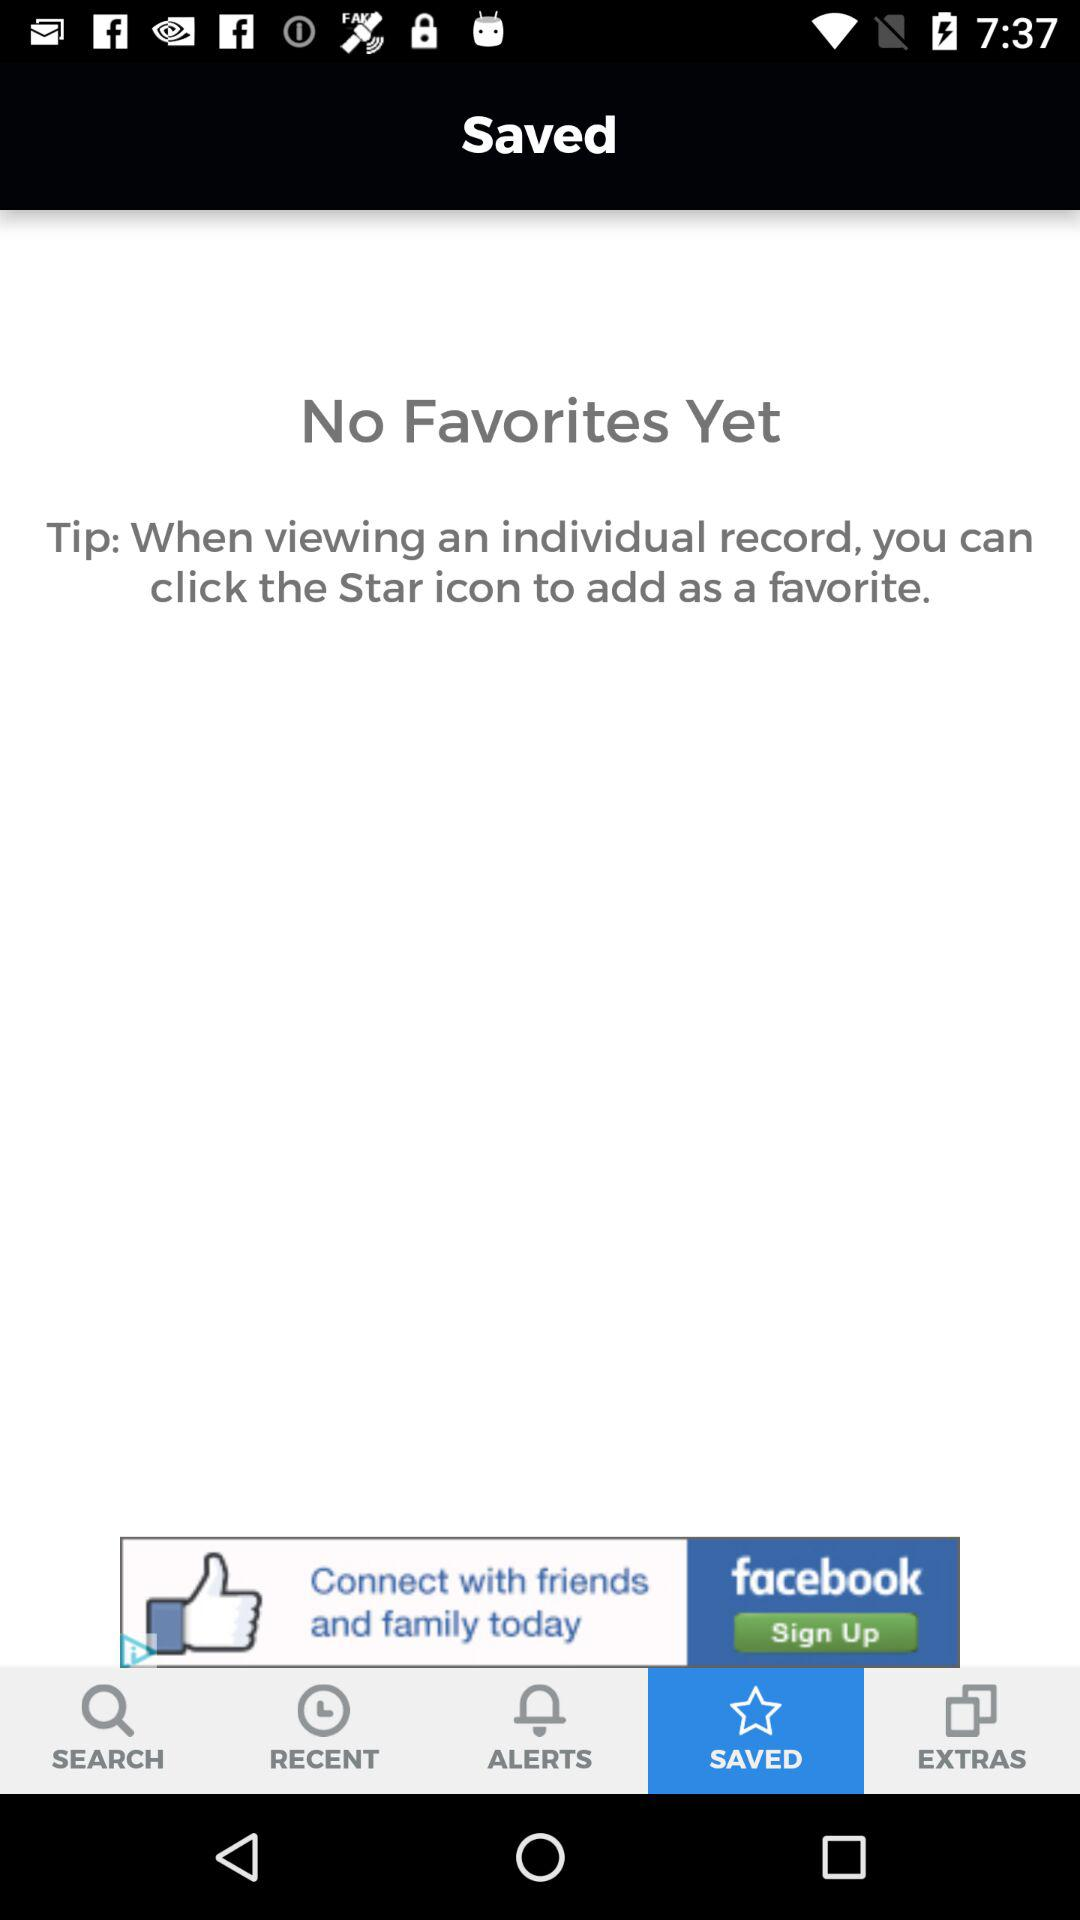How many saved items are there on this screen?
Answer the question using a single word or phrase. 0 